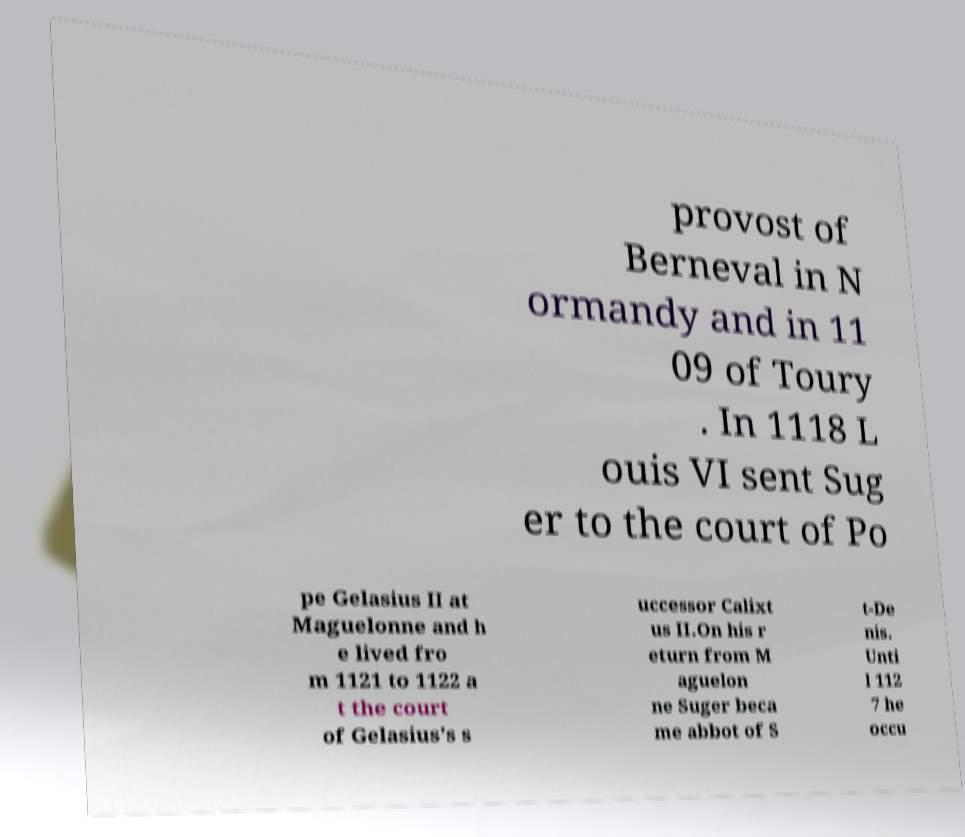Can you read and provide the text displayed in the image?This photo seems to have some interesting text. Can you extract and type it out for me? provost of Berneval in N ormandy and in 11 09 of Toury . In 1118 L ouis VI sent Sug er to the court of Po pe Gelasius II at Maguelonne and h e lived fro m 1121 to 1122 a t the court of Gelasius's s uccessor Calixt us II.On his r eturn from M aguelon ne Suger beca me abbot of S t-De nis. Unti l 112 7 he occu 